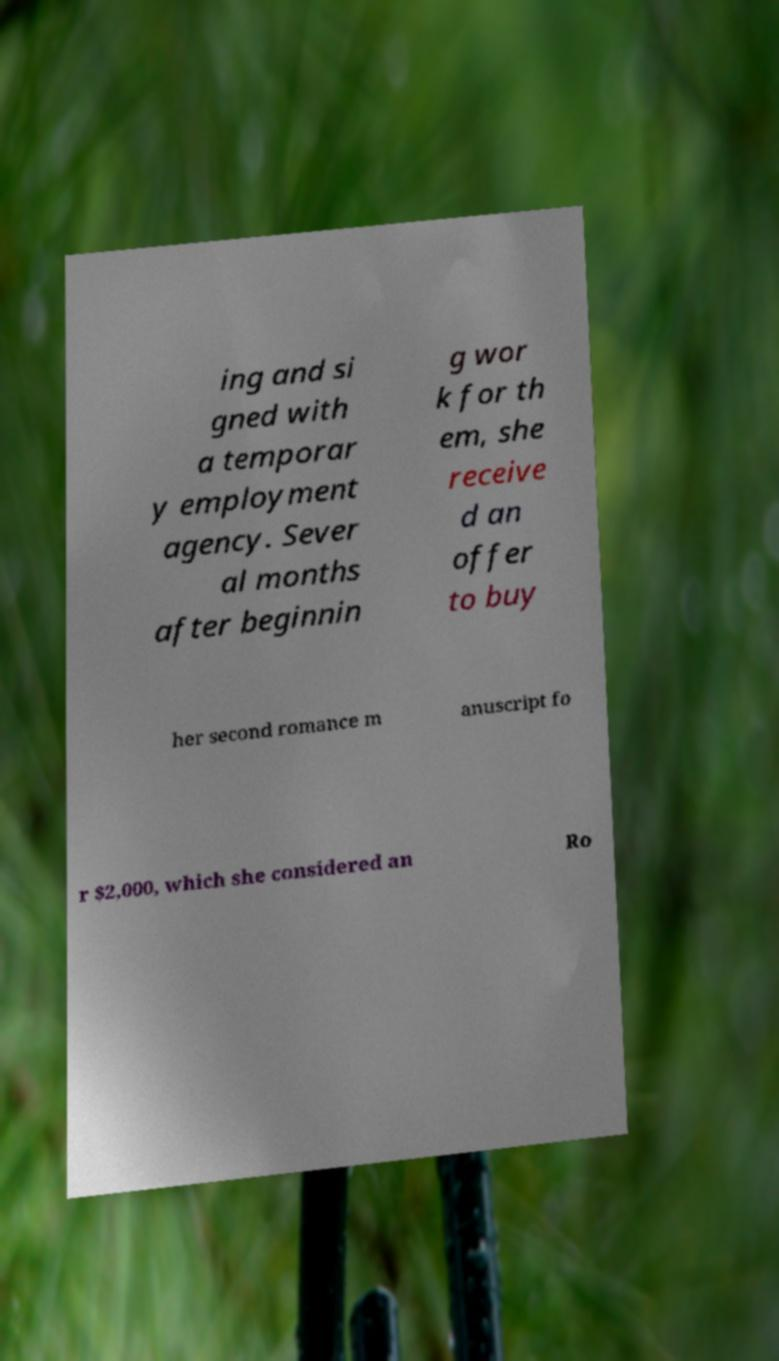I need the written content from this picture converted into text. Can you do that? ing and si gned with a temporar y employment agency. Sever al months after beginnin g wor k for th em, she receive d an offer to buy her second romance m anuscript fo r $2,000, which she considered an Ro 